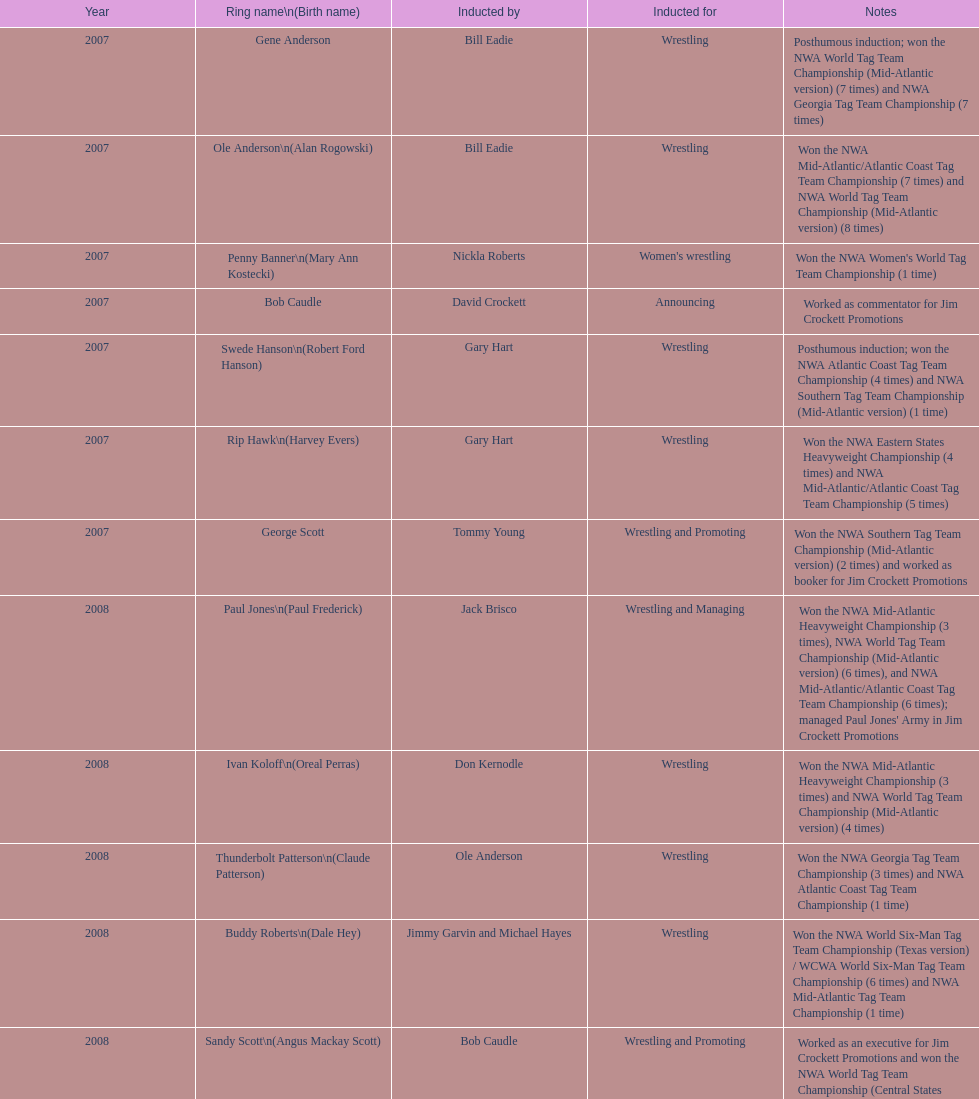Who's real name is dale hey, grizzly smith or buddy roberts? Buddy Roberts. 